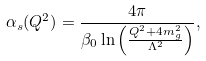<formula> <loc_0><loc_0><loc_500><loc_500>\alpha _ { s } ( Q ^ { 2 } ) = \frac { 4 \pi } { \beta _ { 0 } \ln \left ( \frac { Q ^ { 2 } + 4 m ^ { 2 } _ { g } } { \Lambda ^ { 2 } } \right ) } ,</formula> 